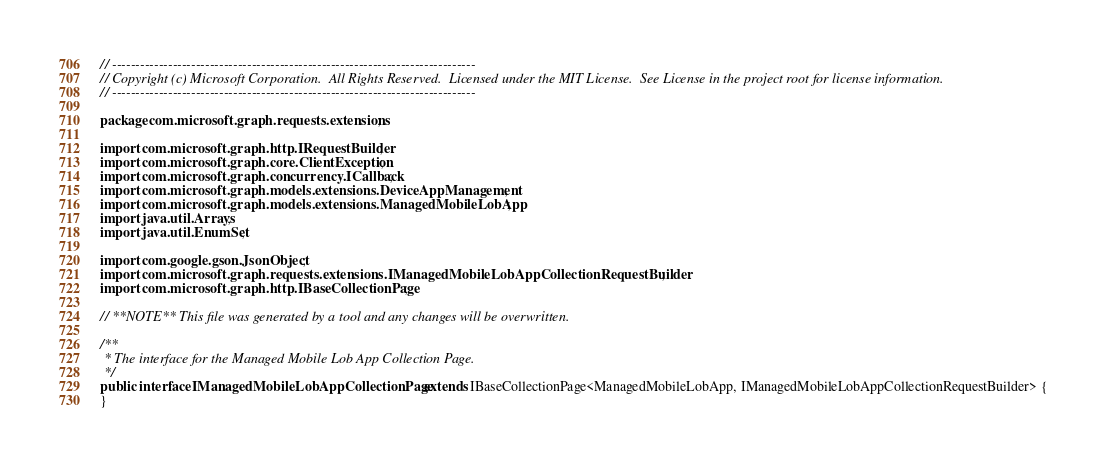Convert code to text. <code><loc_0><loc_0><loc_500><loc_500><_Java_>// ------------------------------------------------------------------------------
// Copyright (c) Microsoft Corporation.  All Rights Reserved.  Licensed under the MIT License.  See License in the project root for license information.
// ------------------------------------------------------------------------------

package com.microsoft.graph.requests.extensions;

import com.microsoft.graph.http.IRequestBuilder;
import com.microsoft.graph.core.ClientException;
import com.microsoft.graph.concurrency.ICallback;
import com.microsoft.graph.models.extensions.DeviceAppManagement;
import com.microsoft.graph.models.extensions.ManagedMobileLobApp;
import java.util.Arrays;
import java.util.EnumSet;

import com.google.gson.JsonObject;
import com.microsoft.graph.requests.extensions.IManagedMobileLobAppCollectionRequestBuilder;
import com.microsoft.graph.http.IBaseCollectionPage;

// **NOTE** This file was generated by a tool and any changes will be overwritten.

/**
 * The interface for the Managed Mobile Lob App Collection Page.
 */
public interface IManagedMobileLobAppCollectionPage extends IBaseCollectionPage<ManagedMobileLobApp, IManagedMobileLobAppCollectionRequestBuilder> {
}
</code> 